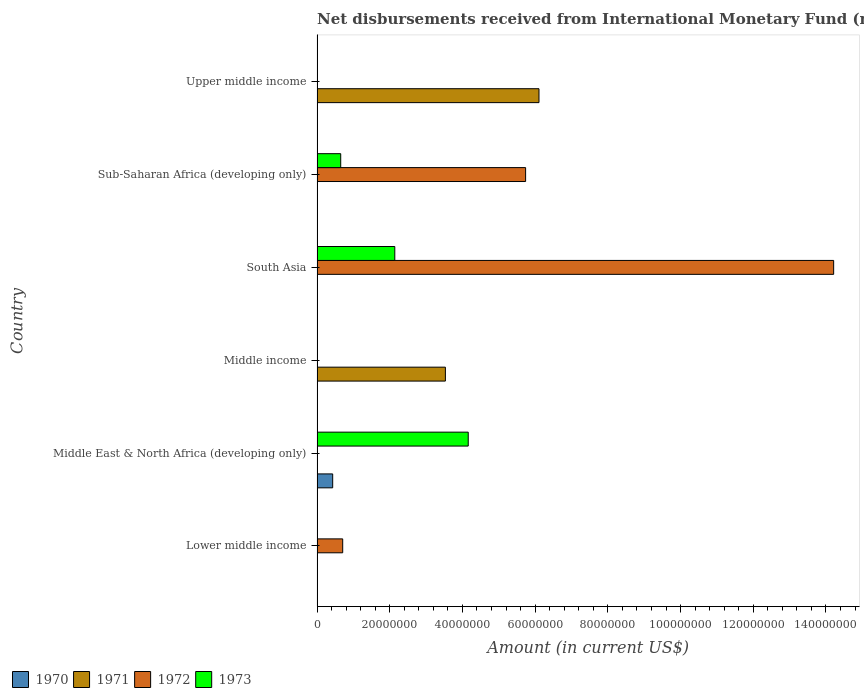Are the number of bars per tick equal to the number of legend labels?
Offer a terse response. No. Are the number of bars on each tick of the Y-axis equal?
Offer a very short reply. No. How many bars are there on the 3rd tick from the top?
Your response must be concise. 2. How many bars are there on the 6th tick from the bottom?
Make the answer very short. 1. What is the label of the 3rd group of bars from the top?
Give a very brief answer. South Asia. In how many cases, is the number of bars for a given country not equal to the number of legend labels?
Your answer should be very brief. 6. What is the amount of disbursements received from International Monetary Fund in 1971 in Middle income?
Your answer should be compact. 3.53e+07. Across all countries, what is the maximum amount of disbursements received from International Monetary Fund in 1972?
Offer a very short reply. 1.42e+08. In which country was the amount of disbursements received from International Monetary Fund in 1971 maximum?
Your answer should be compact. Upper middle income. What is the total amount of disbursements received from International Monetary Fund in 1972 in the graph?
Provide a short and direct response. 2.07e+08. What is the difference between the amount of disbursements received from International Monetary Fund in 1973 in Sub-Saharan Africa (developing only) and the amount of disbursements received from International Monetary Fund in 1971 in Lower middle income?
Give a very brief answer. 6.51e+06. What is the average amount of disbursements received from International Monetary Fund in 1973 per country?
Your answer should be very brief. 1.16e+07. What is the difference between the amount of disbursements received from International Monetary Fund in 1972 and amount of disbursements received from International Monetary Fund in 1973 in South Asia?
Provide a succinct answer. 1.21e+08. In how many countries, is the amount of disbursements received from International Monetary Fund in 1971 greater than 100000000 US$?
Offer a very short reply. 0. What is the ratio of the amount of disbursements received from International Monetary Fund in 1972 in South Asia to that in Sub-Saharan Africa (developing only)?
Your answer should be very brief. 2.48. Is the amount of disbursements received from International Monetary Fund in 1972 in South Asia less than that in Sub-Saharan Africa (developing only)?
Offer a very short reply. No. Is the difference between the amount of disbursements received from International Monetary Fund in 1972 in South Asia and Sub-Saharan Africa (developing only) greater than the difference between the amount of disbursements received from International Monetary Fund in 1973 in South Asia and Sub-Saharan Africa (developing only)?
Give a very brief answer. Yes. What is the difference between the highest and the second highest amount of disbursements received from International Monetary Fund in 1973?
Offer a terse response. 2.02e+07. What is the difference between the highest and the lowest amount of disbursements received from International Monetary Fund in 1971?
Offer a very short reply. 6.11e+07. Are all the bars in the graph horizontal?
Offer a terse response. Yes. How many countries are there in the graph?
Keep it short and to the point. 6. What is the difference between two consecutive major ticks on the X-axis?
Your response must be concise. 2.00e+07. Are the values on the major ticks of X-axis written in scientific E-notation?
Provide a succinct answer. No. Does the graph contain any zero values?
Make the answer very short. Yes. Does the graph contain grids?
Ensure brevity in your answer.  No. How are the legend labels stacked?
Your answer should be compact. Horizontal. What is the title of the graph?
Offer a terse response. Net disbursements received from International Monetary Fund (non-concessional). What is the label or title of the X-axis?
Your response must be concise. Amount (in current US$). What is the label or title of the Y-axis?
Ensure brevity in your answer.  Country. What is the Amount (in current US$) in 1970 in Lower middle income?
Your answer should be compact. 0. What is the Amount (in current US$) in 1972 in Lower middle income?
Your answer should be compact. 7.06e+06. What is the Amount (in current US$) in 1970 in Middle East & North Africa (developing only)?
Your answer should be very brief. 4.30e+06. What is the Amount (in current US$) in 1971 in Middle East & North Africa (developing only)?
Provide a succinct answer. 0. What is the Amount (in current US$) in 1973 in Middle East & North Africa (developing only)?
Your response must be concise. 4.16e+07. What is the Amount (in current US$) in 1970 in Middle income?
Keep it short and to the point. 0. What is the Amount (in current US$) of 1971 in Middle income?
Your answer should be very brief. 3.53e+07. What is the Amount (in current US$) of 1972 in Middle income?
Your answer should be very brief. 0. What is the Amount (in current US$) of 1973 in Middle income?
Offer a very short reply. 0. What is the Amount (in current US$) of 1971 in South Asia?
Ensure brevity in your answer.  0. What is the Amount (in current US$) in 1972 in South Asia?
Offer a very short reply. 1.42e+08. What is the Amount (in current US$) of 1973 in South Asia?
Provide a short and direct response. 2.14e+07. What is the Amount (in current US$) of 1972 in Sub-Saharan Africa (developing only)?
Provide a short and direct response. 5.74e+07. What is the Amount (in current US$) in 1973 in Sub-Saharan Africa (developing only)?
Keep it short and to the point. 6.51e+06. What is the Amount (in current US$) of 1971 in Upper middle income?
Keep it short and to the point. 6.11e+07. What is the Amount (in current US$) in 1973 in Upper middle income?
Ensure brevity in your answer.  0. Across all countries, what is the maximum Amount (in current US$) of 1970?
Make the answer very short. 4.30e+06. Across all countries, what is the maximum Amount (in current US$) in 1971?
Your response must be concise. 6.11e+07. Across all countries, what is the maximum Amount (in current US$) of 1972?
Give a very brief answer. 1.42e+08. Across all countries, what is the maximum Amount (in current US$) of 1973?
Offer a very short reply. 4.16e+07. Across all countries, what is the minimum Amount (in current US$) of 1970?
Give a very brief answer. 0. What is the total Amount (in current US$) in 1970 in the graph?
Provide a succinct answer. 4.30e+06. What is the total Amount (in current US$) of 1971 in the graph?
Your answer should be very brief. 9.64e+07. What is the total Amount (in current US$) in 1972 in the graph?
Provide a short and direct response. 2.07e+08. What is the total Amount (in current US$) of 1973 in the graph?
Ensure brevity in your answer.  6.95e+07. What is the difference between the Amount (in current US$) in 1972 in Lower middle income and that in South Asia?
Your answer should be compact. -1.35e+08. What is the difference between the Amount (in current US$) in 1972 in Lower middle income and that in Sub-Saharan Africa (developing only)?
Offer a terse response. -5.03e+07. What is the difference between the Amount (in current US$) of 1973 in Middle East & North Africa (developing only) and that in South Asia?
Make the answer very short. 2.02e+07. What is the difference between the Amount (in current US$) in 1973 in Middle East & North Africa (developing only) and that in Sub-Saharan Africa (developing only)?
Give a very brief answer. 3.51e+07. What is the difference between the Amount (in current US$) of 1971 in Middle income and that in Upper middle income?
Ensure brevity in your answer.  -2.57e+07. What is the difference between the Amount (in current US$) in 1972 in South Asia and that in Sub-Saharan Africa (developing only)?
Offer a terse response. 8.48e+07. What is the difference between the Amount (in current US$) in 1973 in South Asia and that in Sub-Saharan Africa (developing only)?
Offer a terse response. 1.49e+07. What is the difference between the Amount (in current US$) of 1972 in Lower middle income and the Amount (in current US$) of 1973 in Middle East & North Africa (developing only)?
Give a very brief answer. -3.45e+07. What is the difference between the Amount (in current US$) in 1972 in Lower middle income and the Amount (in current US$) in 1973 in South Asia?
Your answer should be very brief. -1.43e+07. What is the difference between the Amount (in current US$) in 1972 in Lower middle income and the Amount (in current US$) in 1973 in Sub-Saharan Africa (developing only)?
Your answer should be compact. 5.46e+05. What is the difference between the Amount (in current US$) of 1970 in Middle East & North Africa (developing only) and the Amount (in current US$) of 1971 in Middle income?
Offer a terse response. -3.10e+07. What is the difference between the Amount (in current US$) in 1970 in Middle East & North Africa (developing only) and the Amount (in current US$) in 1972 in South Asia?
Provide a short and direct response. -1.38e+08. What is the difference between the Amount (in current US$) of 1970 in Middle East & North Africa (developing only) and the Amount (in current US$) of 1973 in South Asia?
Offer a terse response. -1.71e+07. What is the difference between the Amount (in current US$) in 1970 in Middle East & North Africa (developing only) and the Amount (in current US$) in 1972 in Sub-Saharan Africa (developing only)?
Provide a succinct answer. -5.31e+07. What is the difference between the Amount (in current US$) of 1970 in Middle East & North Africa (developing only) and the Amount (in current US$) of 1973 in Sub-Saharan Africa (developing only)?
Offer a terse response. -2.21e+06. What is the difference between the Amount (in current US$) of 1970 in Middle East & North Africa (developing only) and the Amount (in current US$) of 1971 in Upper middle income?
Your answer should be compact. -5.68e+07. What is the difference between the Amount (in current US$) in 1971 in Middle income and the Amount (in current US$) in 1972 in South Asia?
Your answer should be compact. -1.07e+08. What is the difference between the Amount (in current US$) in 1971 in Middle income and the Amount (in current US$) in 1973 in South Asia?
Ensure brevity in your answer.  1.39e+07. What is the difference between the Amount (in current US$) in 1971 in Middle income and the Amount (in current US$) in 1972 in Sub-Saharan Africa (developing only)?
Provide a short and direct response. -2.21e+07. What is the difference between the Amount (in current US$) of 1971 in Middle income and the Amount (in current US$) of 1973 in Sub-Saharan Africa (developing only)?
Offer a very short reply. 2.88e+07. What is the difference between the Amount (in current US$) of 1972 in South Asia and the Amount (in current US$) of 1973 in Sub-Saharan Africa (developing only)?
Make the answer very short. 1.36e+08. What is the average Amount (in current US$) in 1970 per country?
Provide a short and direct response. 7.17e+05. What is the average Amount (in current US$) of 1971 per country?
Offer a very short reply. 1.61e+07. What is the average Amount (in current US$) of 1972 per country?
Your response must be concise. 3.44e+07. What is the average Amount (in current US$) in 1973 per country?
Give a very brief answer. 1.16e+07. What is the difference between the Amount (in current US$) of 1970 and Amount (in current US$) of 1973 in Middle East & North Africa (developing only)?
Provide a short and direct response. -3.73e+07. What is the difference between the Amount (in current US$) in 1972 and Amount (in current US$) in 1973 in South Asia?
Your answer should be very brief. 1.21e+08. What is the difference between the Amount (in current US$) in 1972 and Amount (in current US$) in 1973 in Sub-Saharan Africa (developing only)?
Your answer should be very brief. 5.09e+07. What is the ratio of the Amount (in current US$) in 1972 in Lower middle income to that in South Asia?
Your answer should be very brief. 0.05. What is the ratio of the Amount (in current US$) in 1972 in Lower middle income to that in Sub-Saharan Africa (developing only)?
Offer a very short reply. 0.12. What is the ratio of the Amount (in current US$) in 1973 in Middle East & North Africa (developing only) to that in South Asia?
Offer a very short reply. 1.94. What is the ratio of the Amount (in current US$) of 1973 in Middle East & North Africa (developing only) to that in Sub-Saharan Africa (developing only)?
Provide a short and direct response. 6.39. What is the ratio of the Amount (in current US$) of 1971 in Middle income to that in Upper middle income?
Your answer should be compact. 0.58. What is the ratio of the Amount (in current US$) of 1972 in South Asia to that in Sub-Saharan Africa (developing only)?
Your response must be concise. 2.48. What is the ratio of the Amount (in current US$) in 1973 in South Asia to that in Sub-Saharan Africa (developing only)?
Provide a short and direct response. 3.29. What is the difference between the highest and the second highest Amount (in current US$) in 1972?
Give a very brief answer. 8.48e+07. What is the difference between the highest and the second highest Amount (in current US$) in 1973?
Offer a terse response. 2.02e+07. What is the difference between the highest and the lowest Amount (in current US$) of 1970?
Ensure brevity in your answer.  4.30e+06. What is the difference between the highest and the lowest Amount (in current US$) of 1971?
Provide a succinct answer. 6.11e+07. What is the difference between the highest and the lowest Amount (in current US$) in 1972?
Offer a very short reply. 1.42e+08. What is the difference between the highest and the lowest Amount (in current US$) in 1973?
Keep it short and to the point. 4.16e+07. 